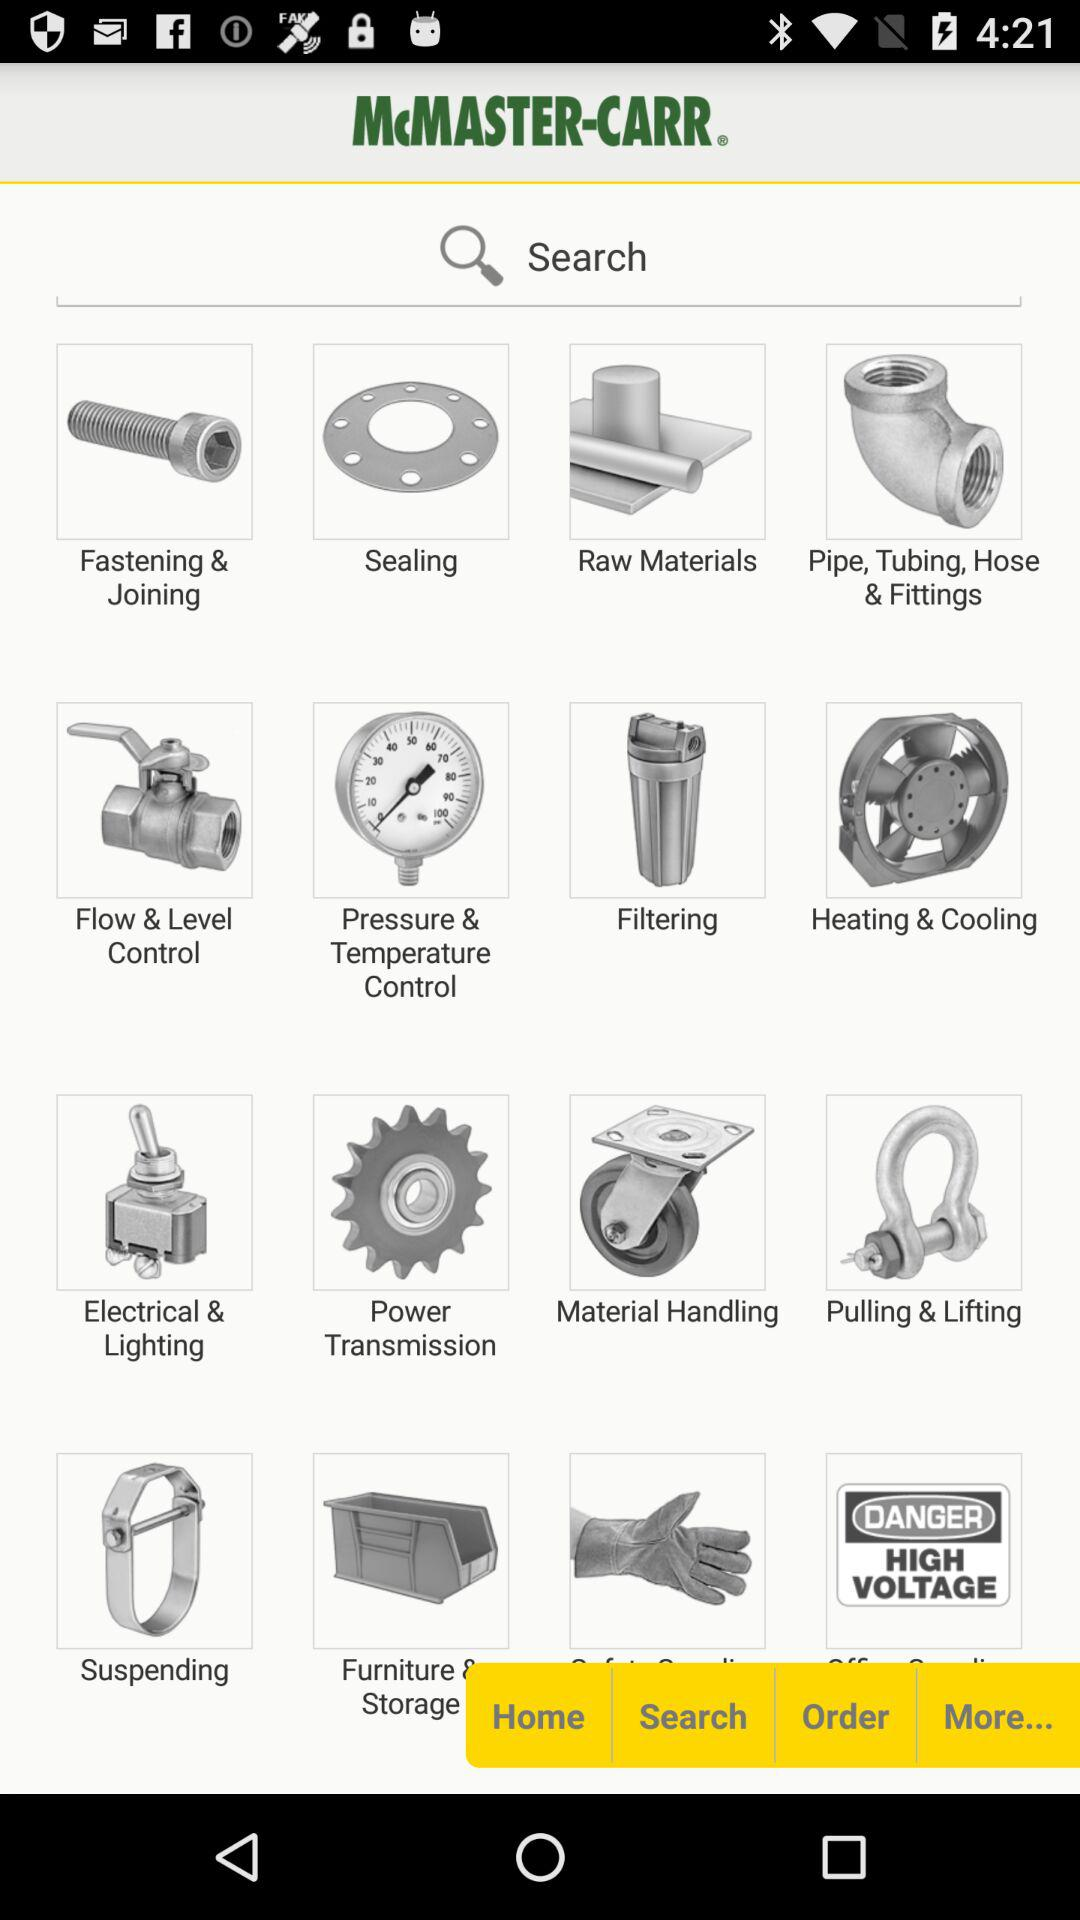What is the name of the application? The name of the application is "McMASTER-CARR". 